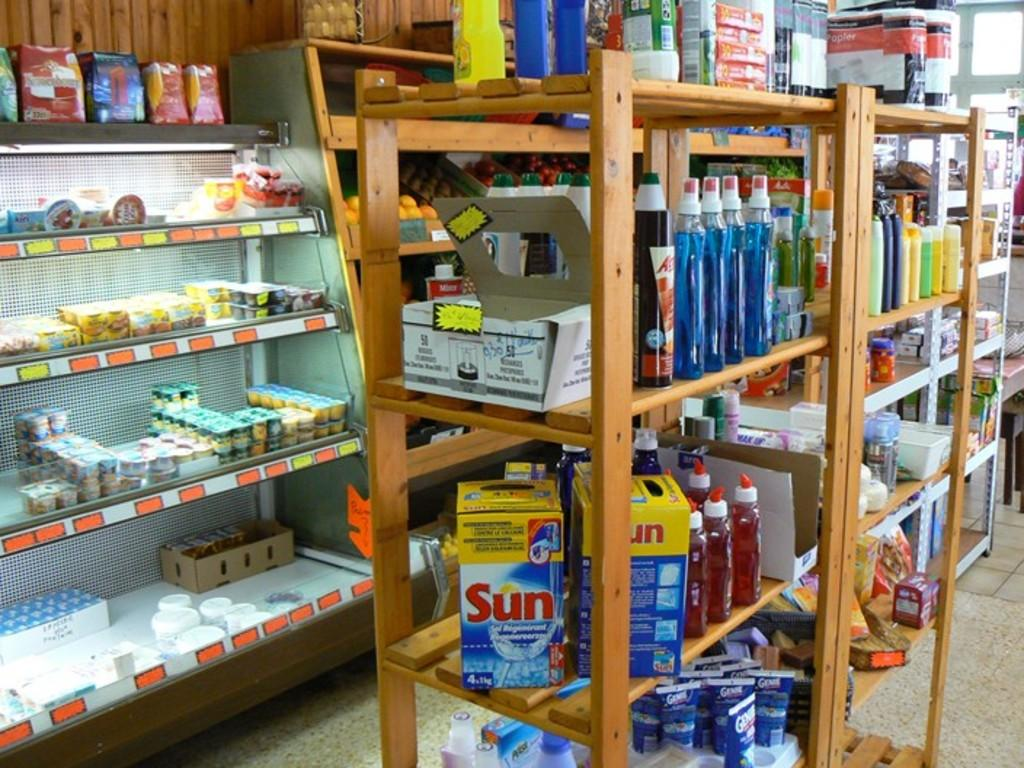<image>
Describe the image concisely. an object that has the word sun written on it 